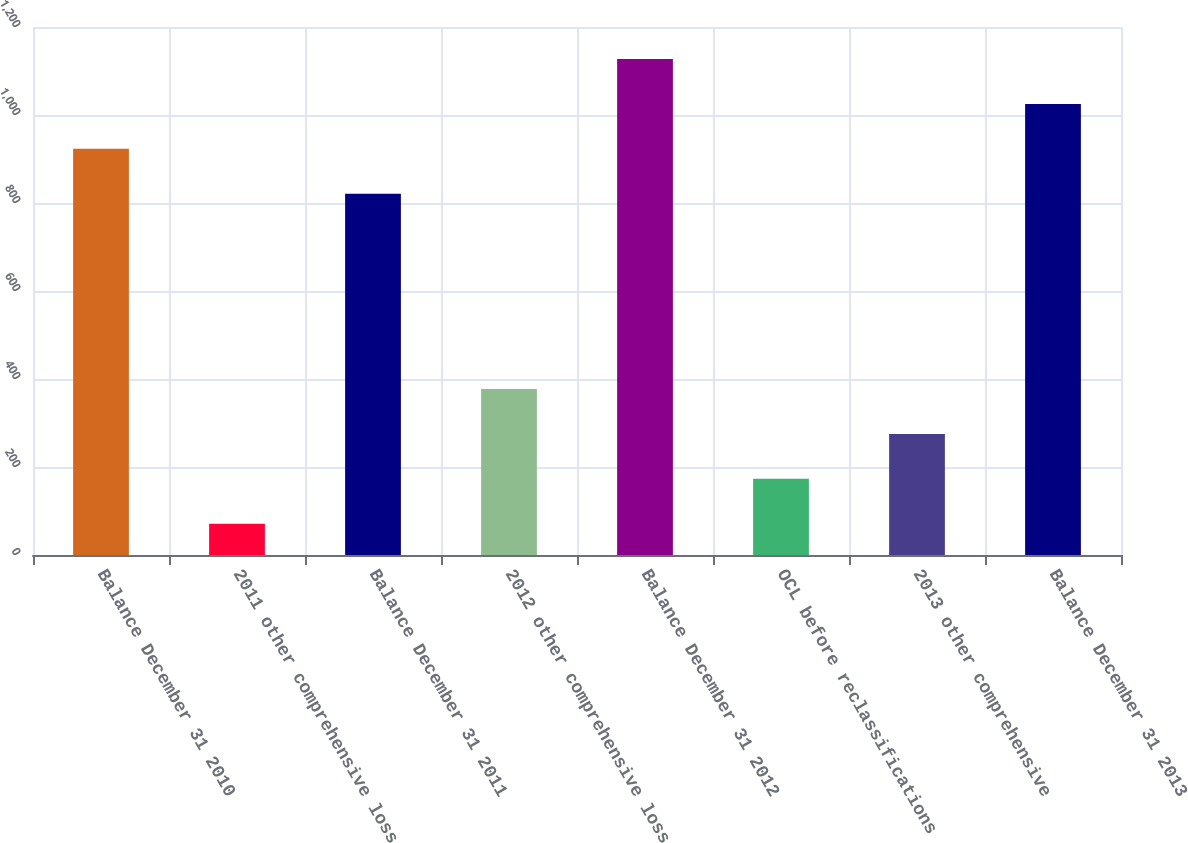<chart> <loc_0><loc_0><loc_500><loc_500><bar_chart><fcel>Balance December 31 2010<fcel>2011 other comprehensive loss<fcel>Balance December 31 2011<fcel>2012 other comprehensive loss<fcel>Balance December 31 2012<fcel>OCL before reclassifications<fcel>2013 other comprehensive<fcel>Balance December 31 2013<nl><fcel>923.1<fcel>71<fcel>821<fcel>377.3<fcel>1127.3<fcel>173.1<fcel>275.2<fcel>1025.2<nl></chart> 